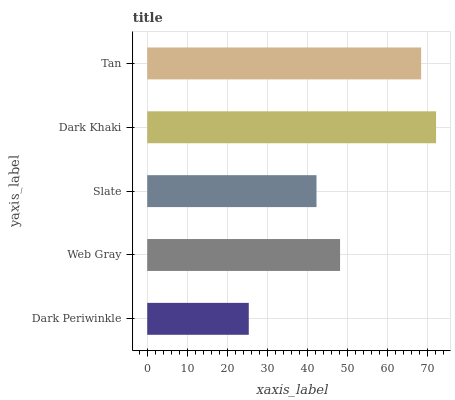Is Dark Periwinkle the minimum?
Answer yes or no. Yes. Is Dark Khaki the maximum?
Answer yes or no. Yes. Is Web Gray the minimum?
Answer yes or no. No. Is Web Gray the maximum?
Answer yes or no. No. Is Web Gray greater than Dark Periwinkle?
Answer yes or no. Yes. Is Dark Periwinkle less than Web Gray?
Answer yes or no. Yes. Is Dark Periwinkle greater than Web Gray?
Answer yes or no. No. Is Web Gray less than Dark Periwinkle?
Answer yes or no. No. Is Web Gray the high median?
Answer yes or no. Yes. Is Web Gray the low median?
Answer yes or no. Yes. Is Dark Periwinkle the high median?
Answer yes or no. No. Is Dark Periwinkle the low median?
Answer yes or no. No. 